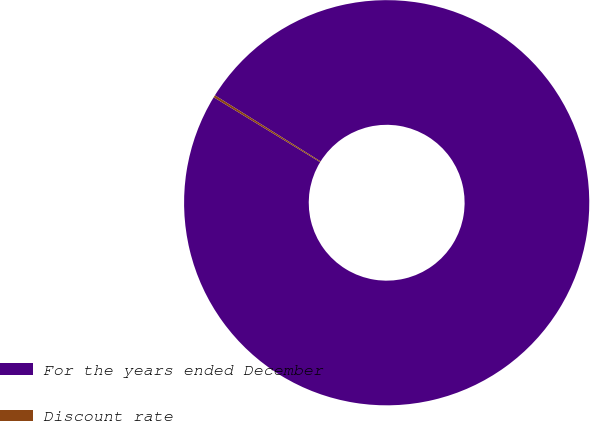Convert chart. <chart><loc_0><loc_0><loc_500><loc_500><pie_chart><fcel>For the years ended December<fcel>Discount rate<nl><fcel>99.82%<fcel>0.18%<nl></chart> 